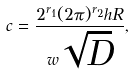Convert formula to latex. <formula><loc_0><loc_0><loc_500><loc_500>c = \frac { 2 ^ { r _ { 1 } } ( 2 \pi ) ^ { r _ { 2 } } h R } { w \sqrt { D } } ,</formula> 